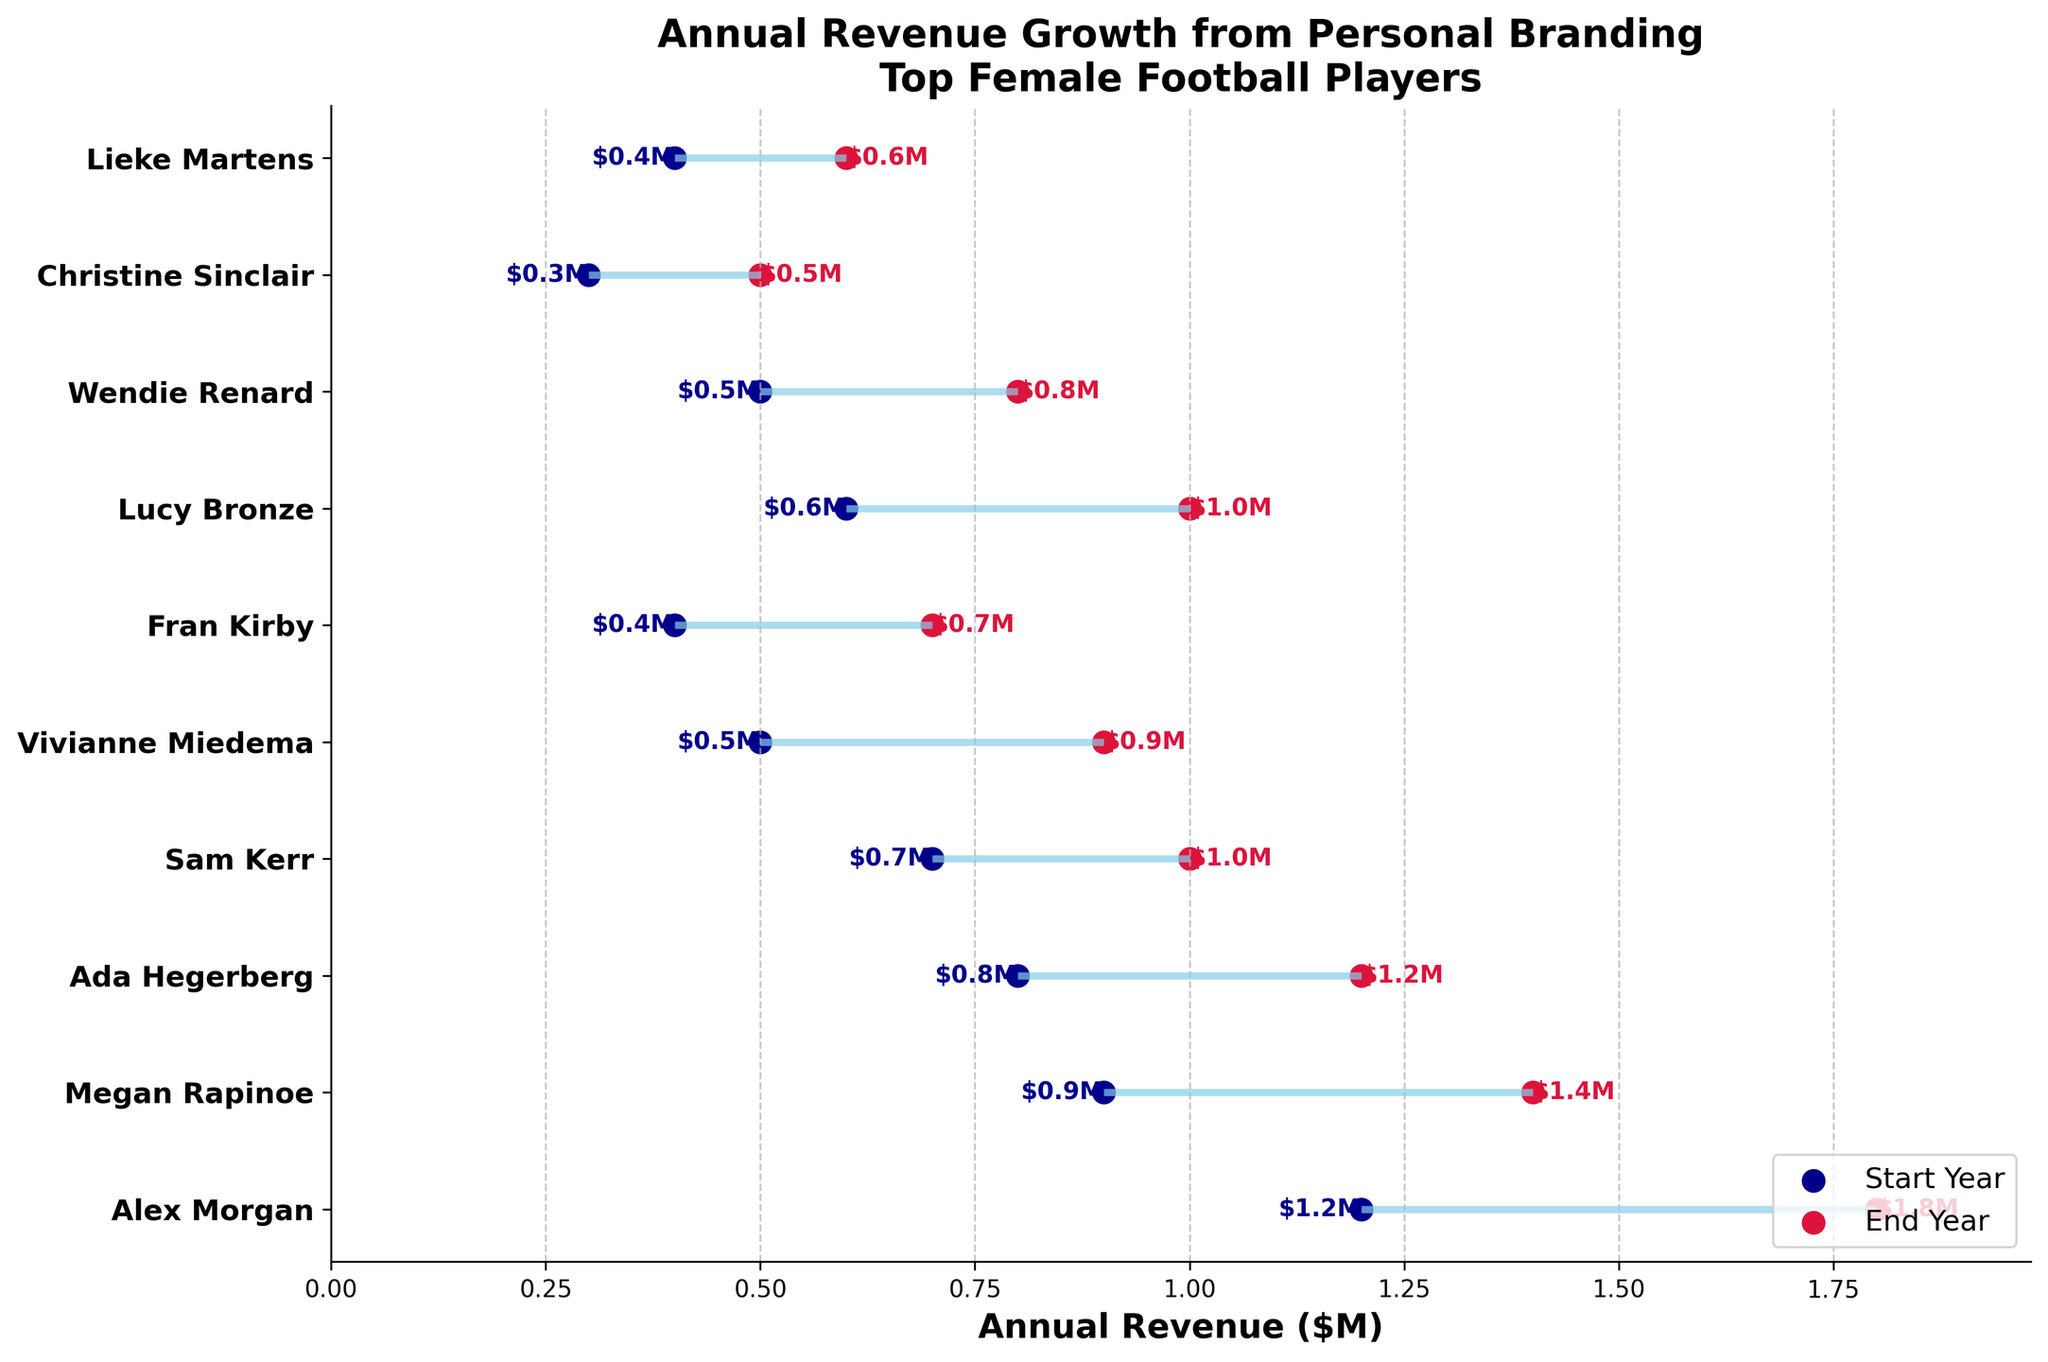What is the title of the plot? The title of the plot is usually displayed at the top of the figure. In this case, it reads "Annual Revenue Growth from Personal Branding\nTop Female Football Players".
Answer: Annual Revenue Growth from Personal Branding\nTop Female Football Players Which player started with the highest revenue? By looking at the start points (dark blue dots) on the x-axis, the player with the highest starting revenue is Alex Morgan with $1.2 million.
Answer: Alex Morgan What are the end year revenues for Megan Rapinoe and Sam Kerr? Checking the end points (crimson dots) on the x-axis for Megan Rapinoe and Sam Kerr, their revenues at the end year are $1.4 million and $1.0 million, respectively.
Answer: Megan Rapinoe: $1.4M, Sam Kerr: $1M What is the difference in end year revenue between Ada Hegerberg and Lucy Bronze? Compare the end points for Ada Hegerberg and Lucy Bronze. Ada Hegerberg's end year revenue is $1.2 million and Lucy Bronze's is $1.0 million. The difference is $1.2M - $1.0M = $0.2 million.
Answer: $0.2M Which two players have the lowest end year revenues? Observing the crimson dots for the lowest values, the players with the lowest end year revenues are Christine Sinclair and Lieke Martens with $0.5 million and $0.6 million, respectively.
Answer: Christine Sinclair, Lieke Martens Who experienced the largest increase in revenue from the start to end year? Calculate the revenue increases for each player. Alex Morgan increased from $1.2M to $1.8M, a difference of $0.6M. This is the largest increase observed.
Answer: Alex Morgan How many players have an end year revenue of $1 million or more? Count the crimson dots at $1 million or higher. The players are Alex Morgan, Megan Rapinoe, Ada Hegerberg, Sam Kerr, and Lucy Bronze, making a total of 5.
Answer: 5 What is the average end year revenue? Add all end year revenues: $1.8M + $1.4M + $1.2M + $1M + $0.9M + $0.7M + $1M + $0.8M + $0.5M + $0.6M = $9.9M. Divide by the number of players (10). $9.9M / 10 = $0.99 million.
Answer: $0.99M Between which players is the difference in end year revenue exactly $0.5 million? Compare the end year revenue differences. Wendie Renard ($0.8M) and Megan Rapinoe ($1.4M) have a difference of $1.4M - $0.8M = $0.5 million.
Answer: Wendie Renard and Megan Rapinoe What is the median start year revenue? List start year revenues: $0.3M, $0.4M, $0.4M, $0.5M, $0.5M, $0.6M, $0.7M, $0.8M, $0.9M, $1.2M. With 10 values, the median is the average of the 5th and 6th values: ($0.5M + $0.6M) / 2 = $0.55 million.
Answer: $0.55M 